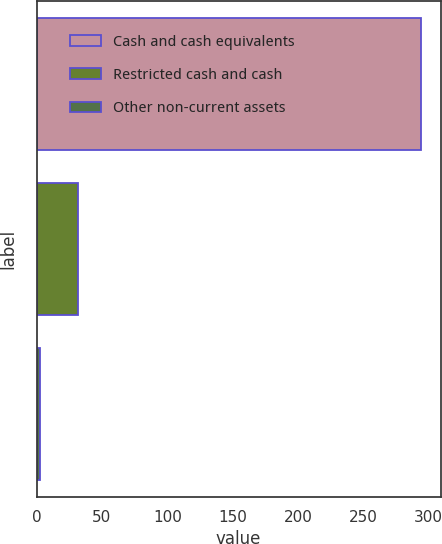Convert chart. <chart><loc_0><loc_0><loc_500><loc_500><bar_chart><fcel>Cash and cash equivalents<fcel>Restricted cash and cash<fcel>Other non-current assets<nl><fcel>294.5<fcel>31.5<fcel>3<nl></chart> 